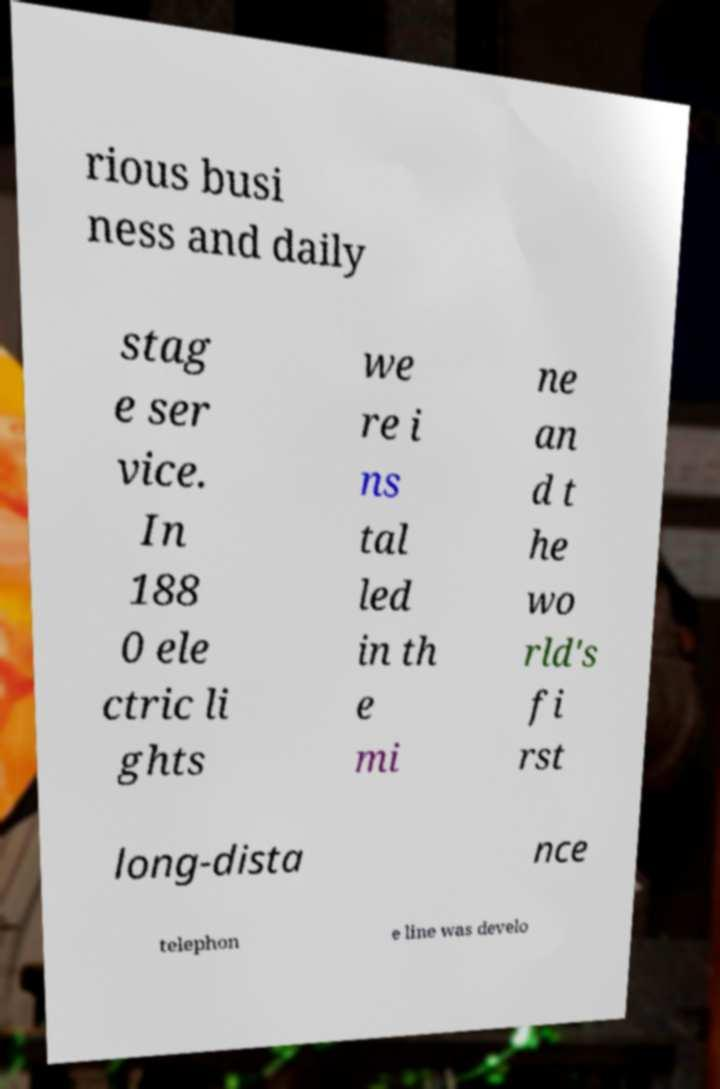Could you assist in decoding the text presented in this image and type it out clearly? rious busi ness and daily stag e ser vice. In 188 0 ele ctric li ghts we re i ns tal led in th e mi ne an d t he wo rld's fi rst long-dista nce telephon e line was develo 